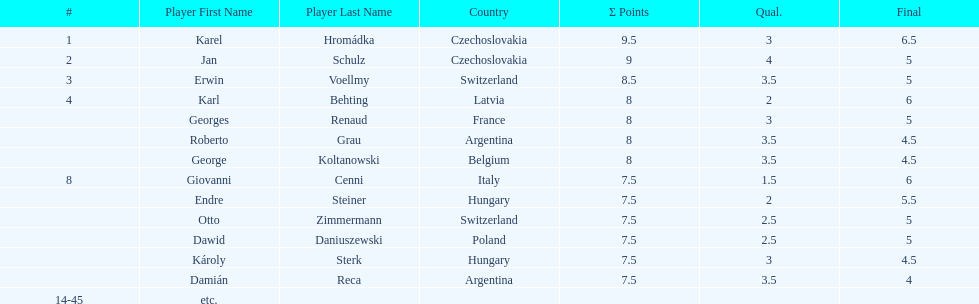Karl behting and giovanni cenni each had final scores of what? 6. 